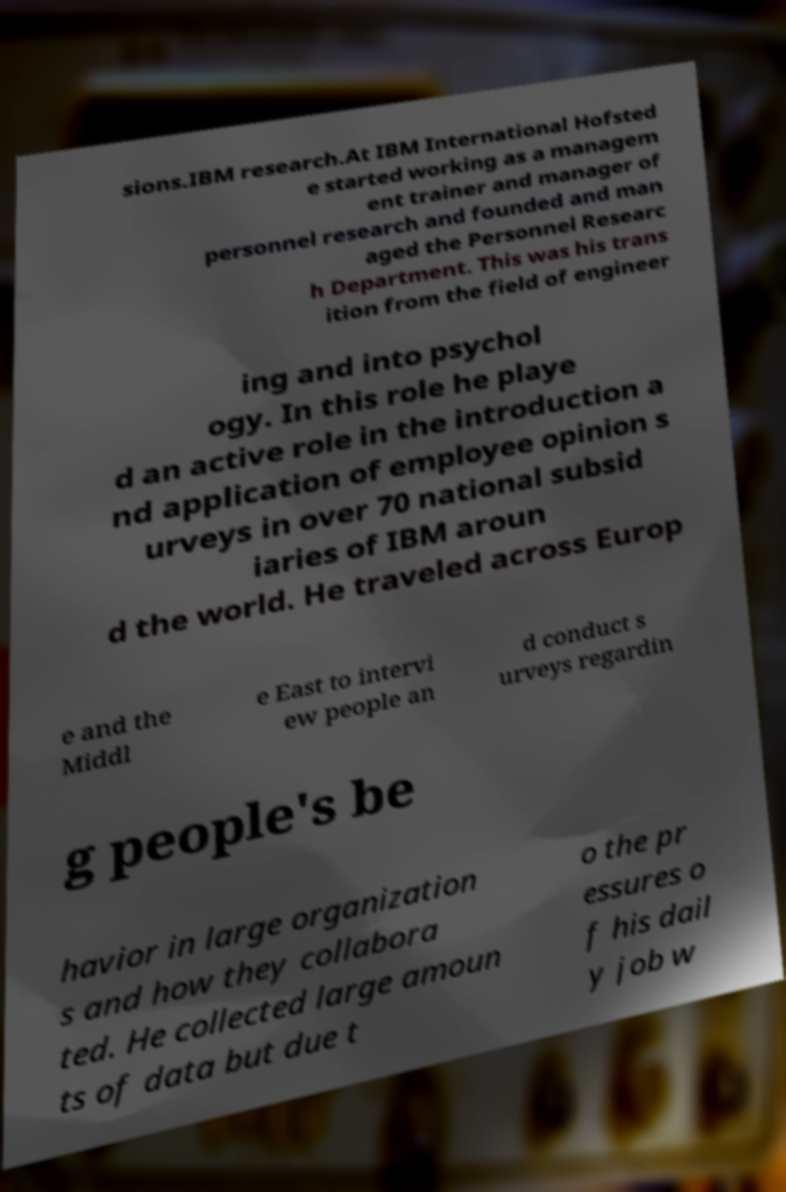What messages or text are displayed in this image? I need them in a readable, typed format. sions.IBM research.At IBM International Hofsted e started working as a managem ent trainer and manager of personnel research and founded and man aged the Personnel Researc h Department. This was his trans ition from the field of engineer ing and into psychol ogy. In this role he playe d an active role in the introduction a nd application of employee opinion s urveys in over 70 national subsid iaries of IBM aroun d the world. He traveled across Europ e and the Middl e East to intervi ew people an d conduct s urveys regardin g people's be havior in large organization s and how they collabora ted. He collected large amoun ts of data but due t o the pr essures o f his dail y job w 